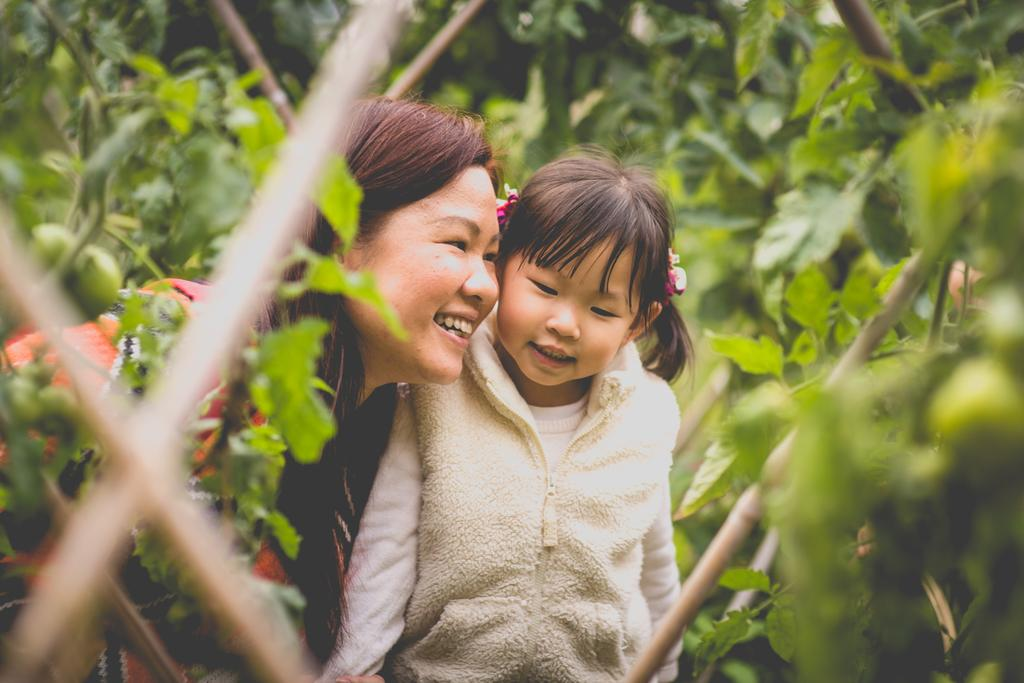How many people are in the image? There are two persons standing in the middle of the image. What are the people in the image doing? The persons are smiling. What can be seen in the background of the image? There are trees and plants, as well as a fencing, in the background. What type of fiction is the baby reading in the image? There is no baby or fiction present in the image. 